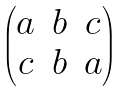Convert formula to latex. <formula><loc_0><loc_0><loc_500><loc_500>\begin{pmatrix} a & b & c \\ c & b & a \end{pmatrix}</formula> 